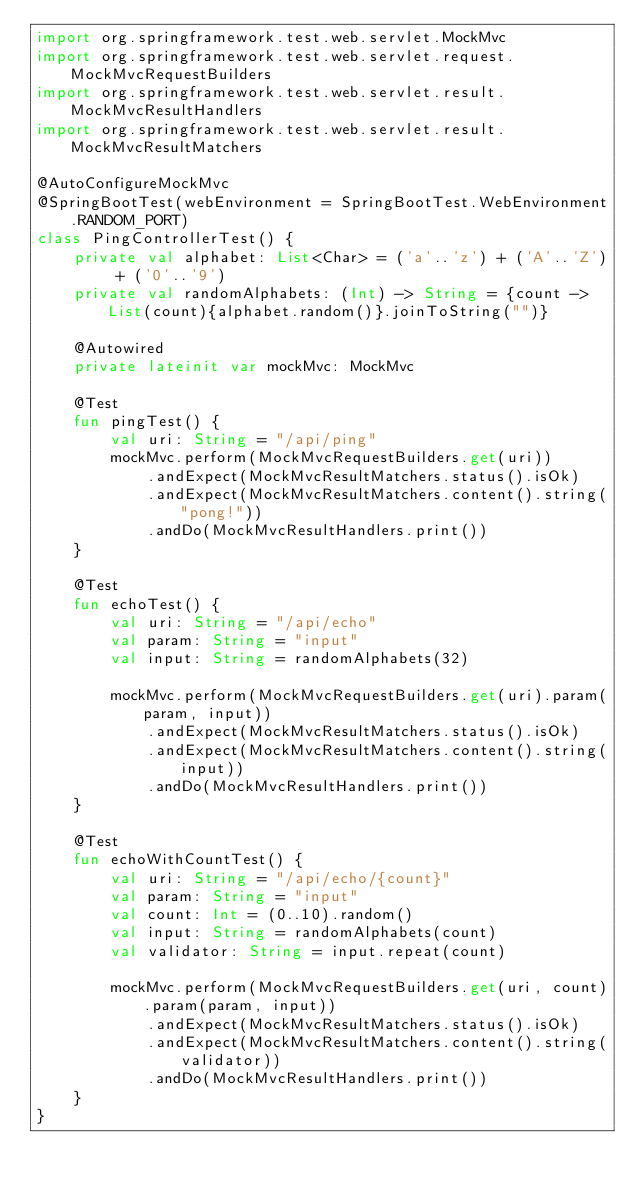Convert code to text. <code><loc_0><loc_0><loc_500><loc_500><_Kotlin_>import org.springframework.test.web.servlet.MockMvc
import org.springframework.test.web.servlet.request.MockMvcRequestBuilders
import org.springframework.test.web.servlet.result.MockMvcResultHandlers
import org.springframework.test.web.servlet.result.MockMvcResultMatchers

@AutoConfigureMockMvc
@SpringBootTest(webEnvironment = SpringBootTest.WebEnvironment.RANDOM_PORT)
class PingControllerTest() {
    private val alphabet: List<Char> = ('a'..'z') + ('A'..'Z') + ('0'..'9')
    private val randomAlphabets: (Int) -> String = {count -> List(count){alphabet.random()}.joinToString("")}

    @Autowired
    private lateinit var mockMvc: MockMvc

    @Test
    fun pingTest() {
        val uri: String = "/api/ping"
        mockMvc.perform(MockMvcRequestBuilders.get(uri))
            .andExpect(MockMvcResultMatchers.status().isOk)
            .andExpect(MockMvcResultMatchers.content().string("pong!"))
            .andDo(MockMvcResultHandlers.print())
    }

    @Test
    fun echoTest() {
        val uri: String = "/api/echo"
        val param: String = "input"
        val input: String = randomAlphabets(32)

        mockMvc.perform(MockMvcRequestBuilders.get(uri).param(param, input))
            .andExpect(MockMvcResultMatchers.status().isOk)
            .andExpect(MockMvcResultMatchers.content().string(input))
            .andDo(MockMvcResultHandlers.print())
    }

    @Test
    fun echoWithCountTest() {
        val uri: String = "/api/echo/{count}"
        val param: String = "input"
        val count: Int = (0..10).random()
        val input: String = randomAlphabets(count)
        val validator: String = input.repeat(count)

        mockMvc.perform(MockMvcRequestBuilders.get(uri, count).param(param, input))
            .andExpect(MockMvcResultMatchers.status().isOk)
            .andExpect(MockMvcResultMatchers.content().string(validator))
            .andDo(MockMvcResultHandlers.print())
    }
}
</code> 